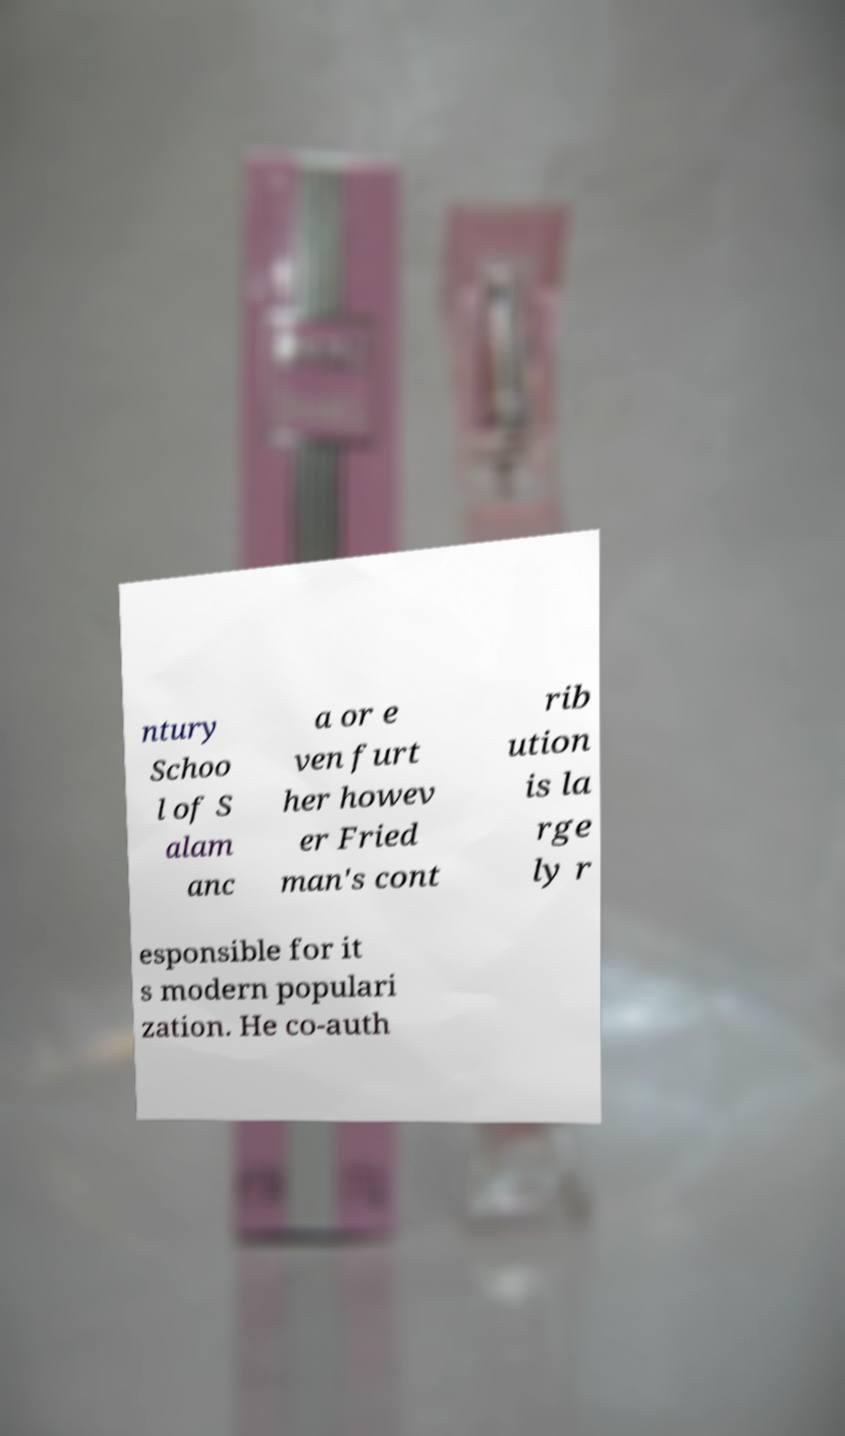There's text embedded in this image that I need extracted. Can you transcribe it verbatim? ntury Schoo l of S alam anc a or e ven furt her howev er Fried man's cont rib ution is la rge ly r esponsible for it s modern populari zation. He co-auth 